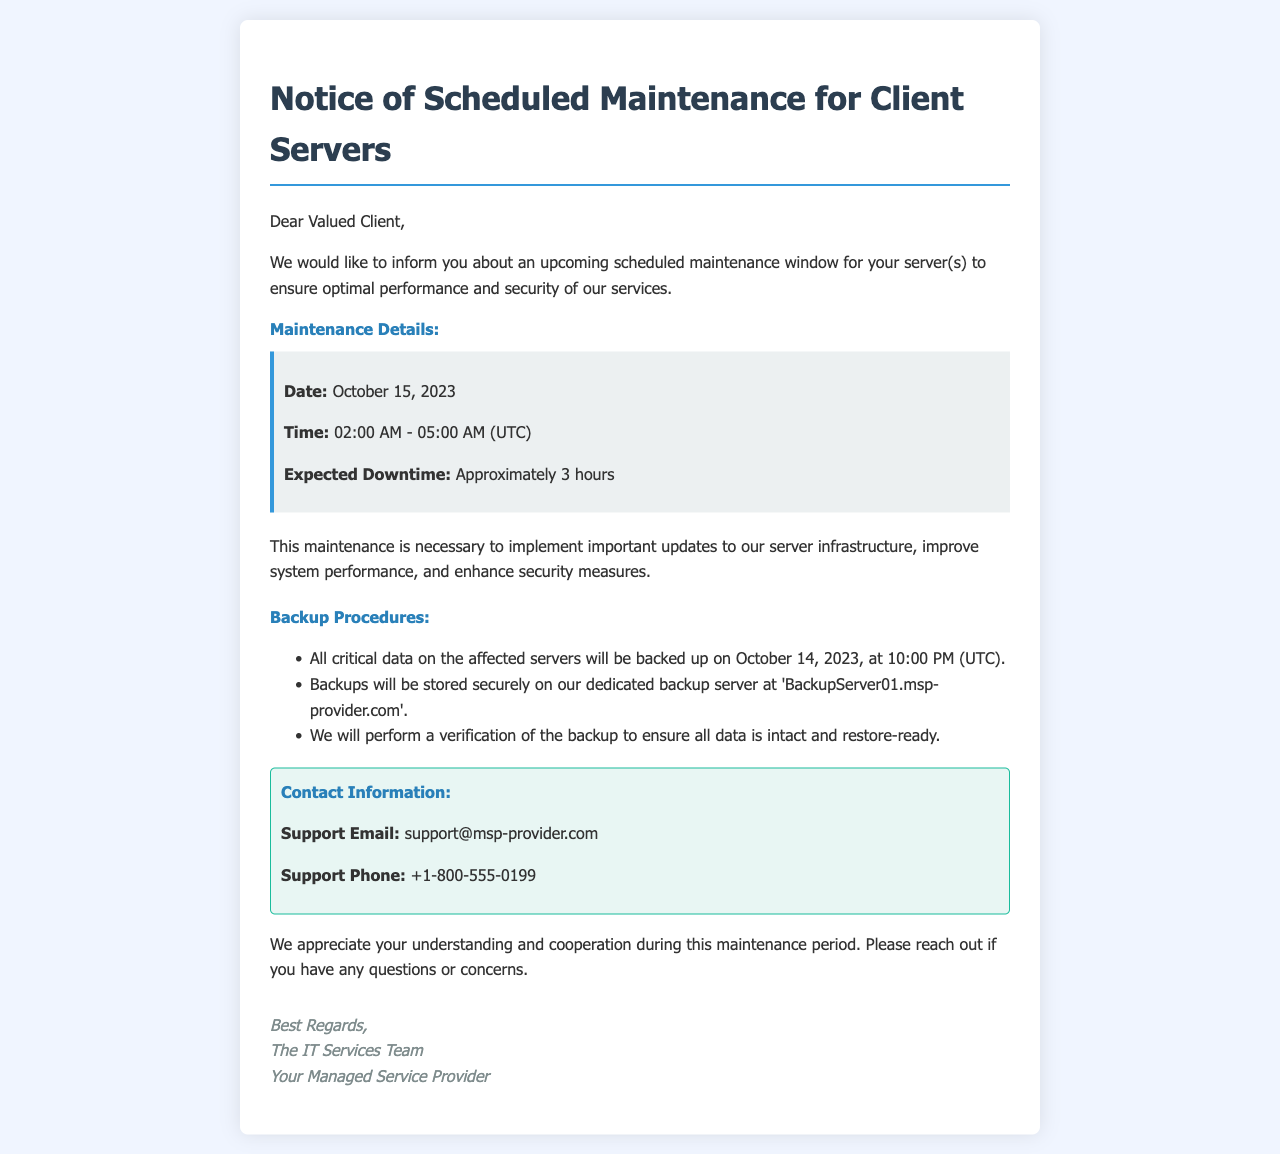What is the maintenance date? The maintenance date is explicitly mentioned in the document as October 15, 2023.
Answer: October 15, 2023 What time will the maintenance occur? The document specifies the maintenance time as 02:00 AM - 05:00 AM (UTC).
Answer: 02:00 AM - 05:00 AM (UTC) How long is the expected downtime? The document states that the expected downtime is approximately 3 hours.
Answer: Approximately 3 hours When will the backup take place? The document mentions that the backup will be performed on October 14, 2023, at 10:00 PM (UTC).
Answer: October 14, 2023, at 10:00 PM (UTC) Where will backups be stored? The document provides the storage location for backups as 'BackupServer01.msp-provider.com'.
Answer: BackupServer01.msp-provider.com What is the support email? The support email is specified in the contact information section of the document.
Answer: support@msp-provider.com Why is the maintenance necessary? The document states that the maintenance is necessary to implement important updates and enhance security measures.
Answer: Important updates and enhance security measures Who signed the document? The signature section identifies the sender as "The IT Services Team".
Answer: The IT Services Team 